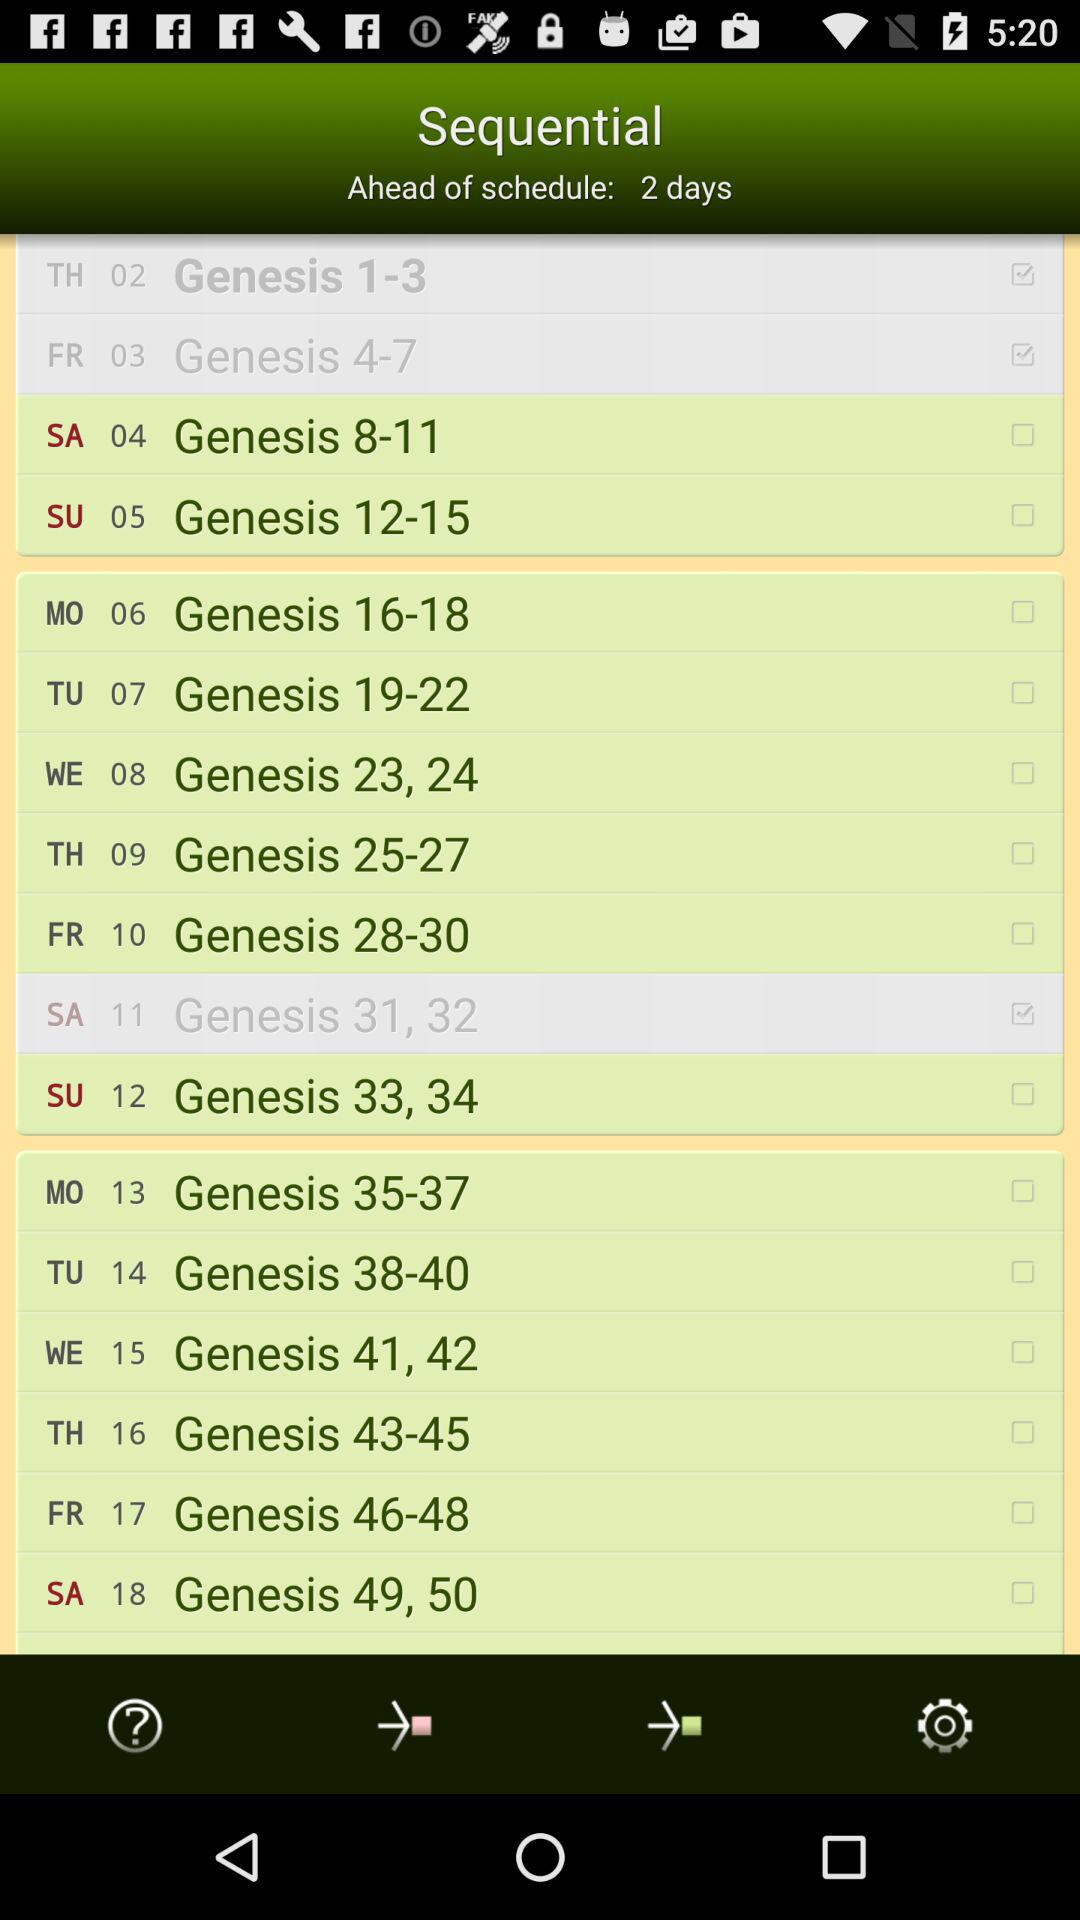How many days ahead of schedule is the user?
Answer the question using a single word or phrase. 2 days 